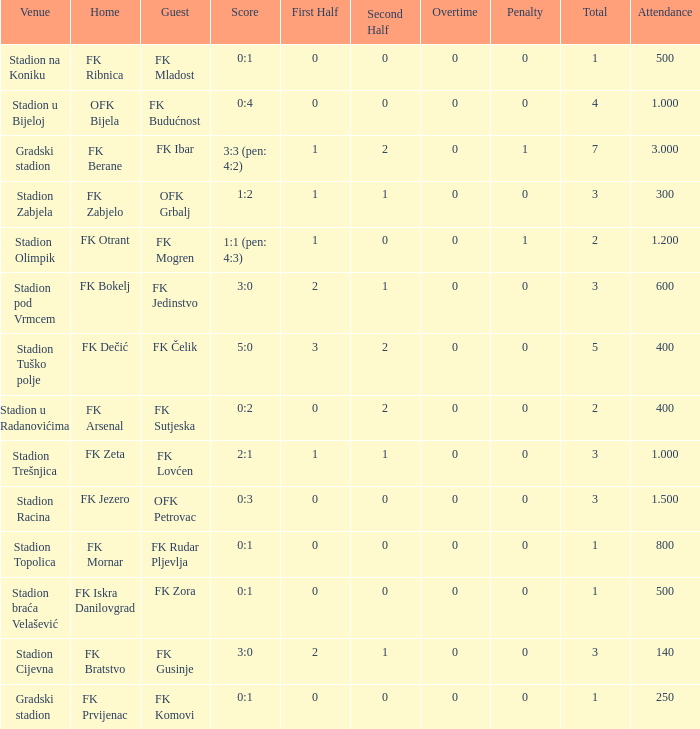What was the score for the game with FK Bratstvo as home team? 3:0. 